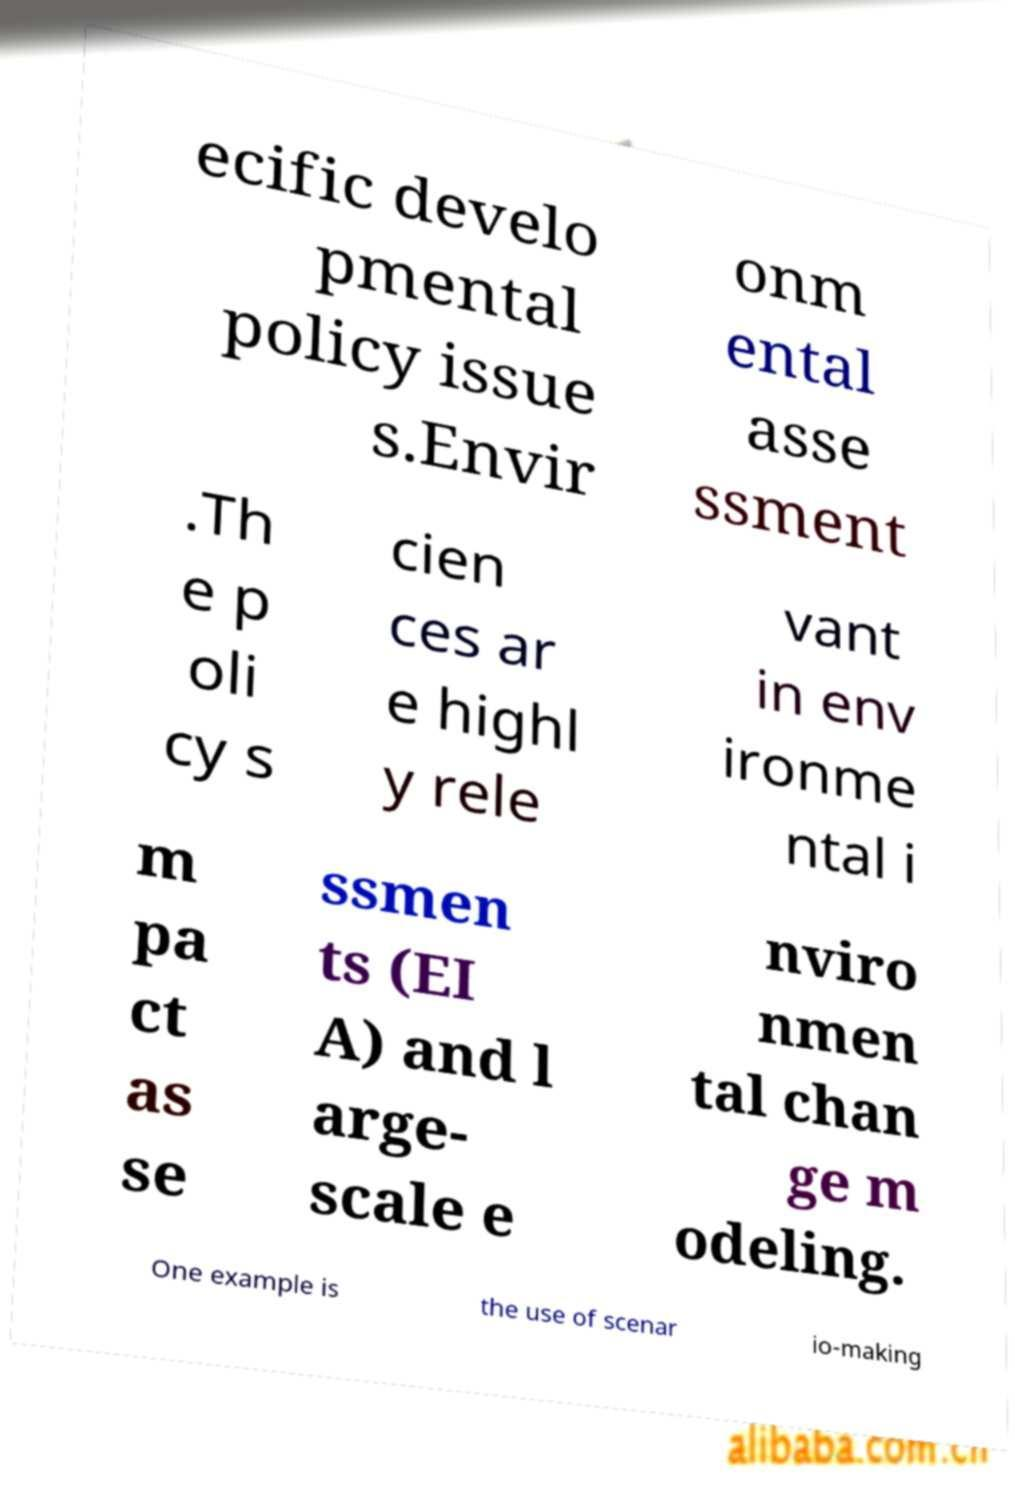Can you read and provide the text displayed in the image?This photo seems to have some interesting text. Can you extract and type it out for me? ecific develo pmental policy issue s.Envir onm ental asse ssment .Th e p oli cy s cien ces ar e highl y rele vant in env ironme ntal i m pa ct as se ssmen ts (EI A) and l arge- scale e nviro nmen tal chan ge m odeling. One example is the use of scenar io-making 